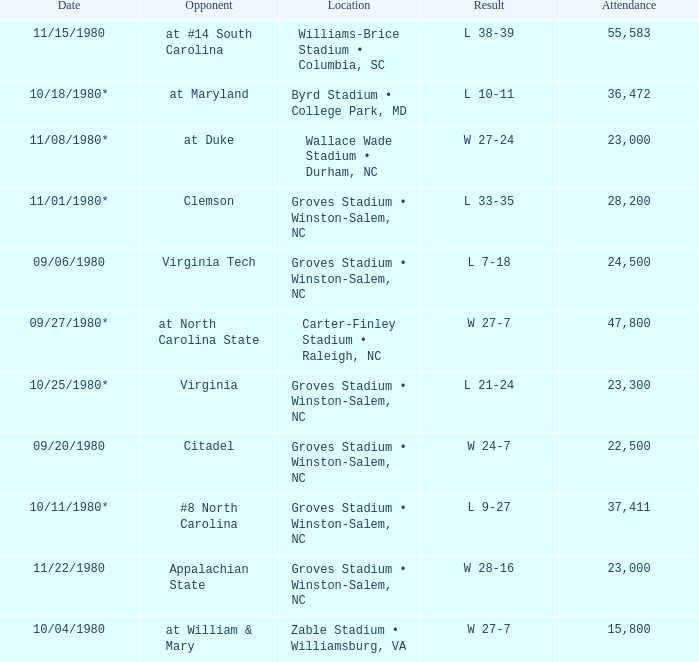How many individuals were present during the wake forest vs virginia tech game? 24500.0. 